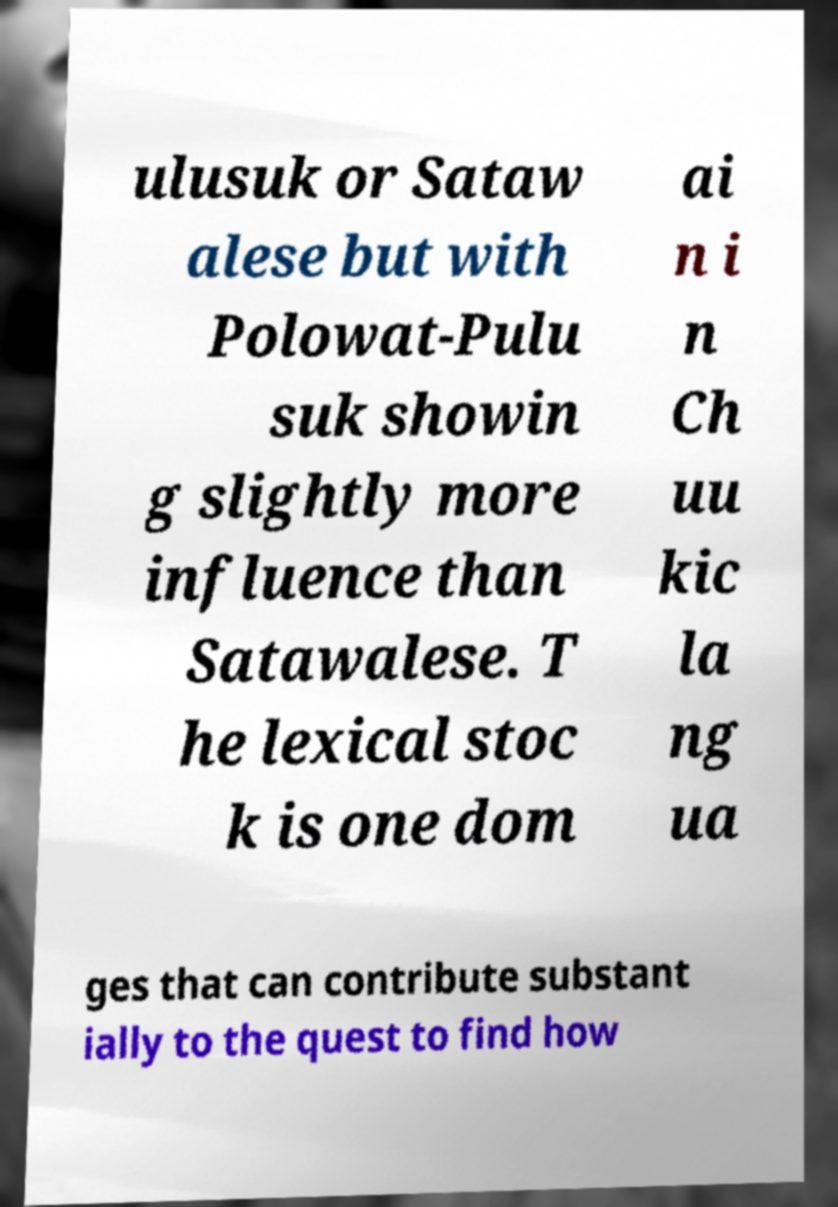Please read and relay the text visible in this image. What does it say? ulusuk or Sataw alese but with Polowat-Pulu suk showin g slightly more influence than Satawalese. T he lexical stoc k is one dom ai n i n Ch uu kic la ng ua ges that can contribute substant ially to the quest to find how 